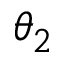<formula> <loc_0><loc_0><loc_500><loc_500>\theta _ { 2 }</formula> 